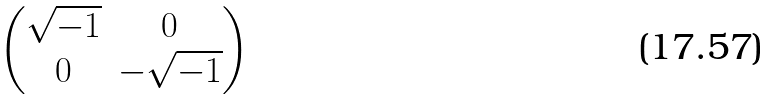Convert formula to latex. <formula><loc_0><loc_0><loc_500><loc_500>\begin{pmatrix} \sqrt { - 1 } & 0 \\ 0 & - \sqrt { - 1 } \end{pmatrix}</formula> 